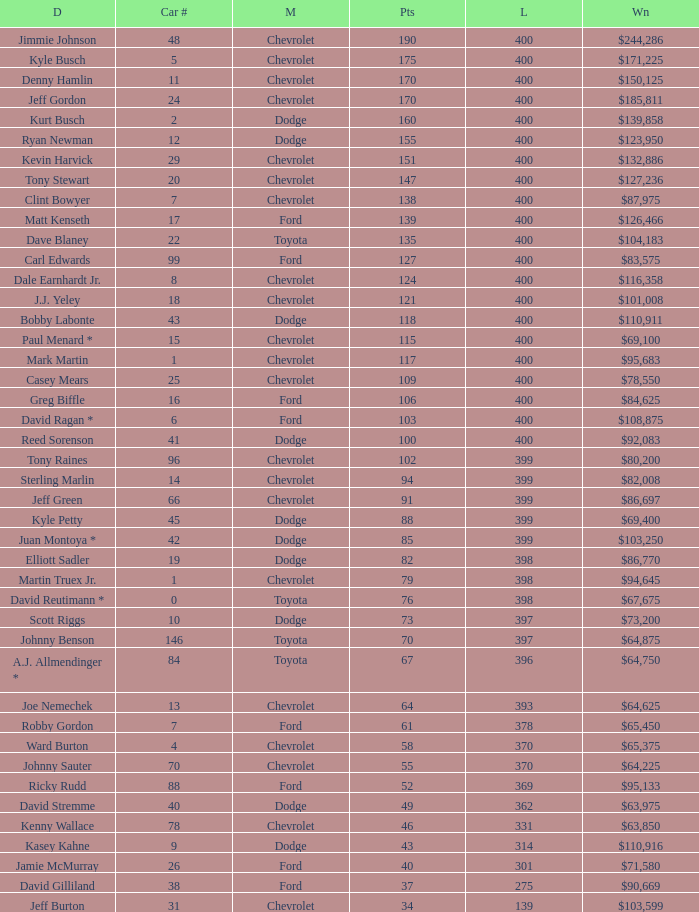What is the car number that has less than 369 laps for a Dodge with more than 49 points? None. 